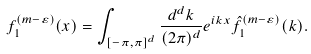Convert formula to latex. <formula><loc_0><loc_0><loc_500><loc_500>f _ { 1 } ^ { ( m - \varepsilon ) } ( x ) = \int _ { [ - \pi , \pi ] ^ { d } } \frac { d ^ { d } k } { ( 2 \pi ) ^ { d } } e ^ { i k x } { { \hat { f } } _ { 1 } } ^ { ( m - \varepsilon ) } ( k ) .</formula> 